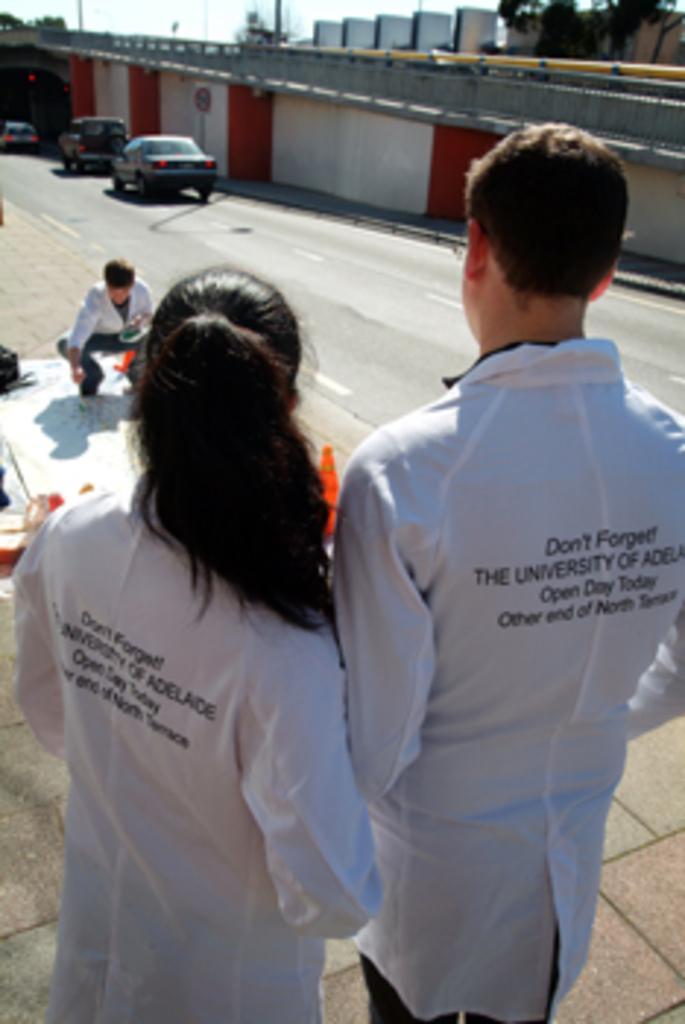Describe this image in one or two sentences. This is an outside view. Here I can see a women and a man are wearing white color jackets, standing on the ground facing towards the back side. On the left side there is a board on the ground. On the board a person is sitting. In the background there are few cars on the road. Beside the road there is a wall. At the top of the image I can see few trees and buildings. 